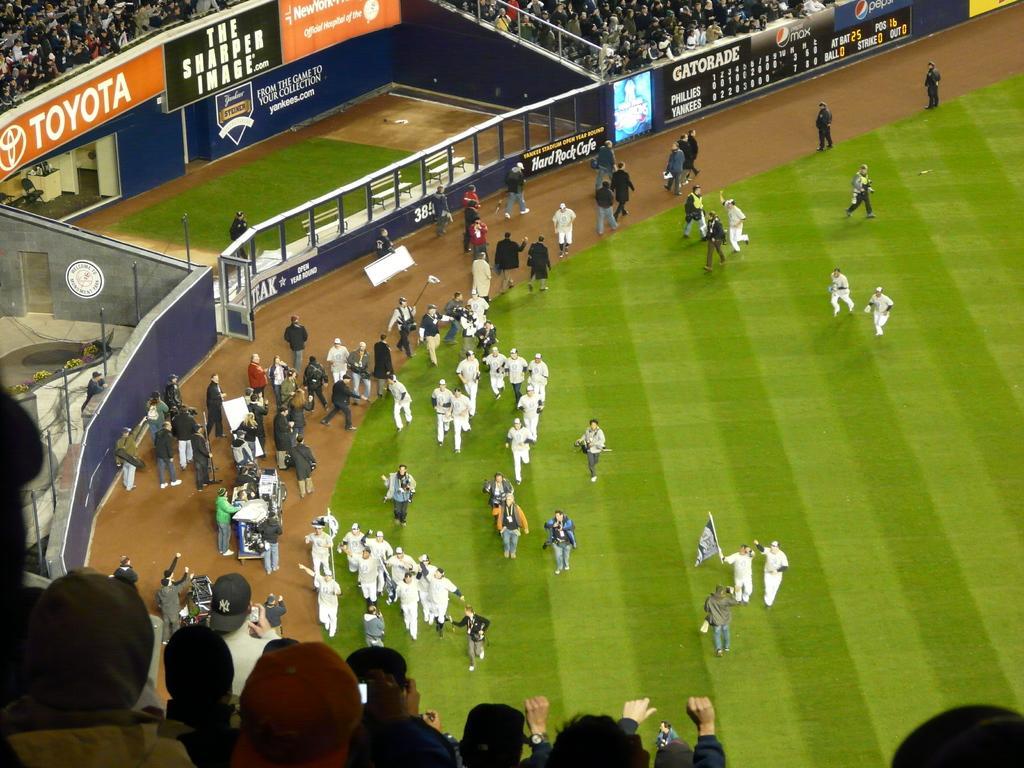Please provide a concise description of this image. In this image we can see a group of people standing on the ground, some people are holding some devices in their hands. One person is holding a flag in his hand. In the center of the image we can see a door, boards with some text and a screen. On the left side of the image we can see some plants and chairs placed on the ground. In the background of the image we can see group of audience. 